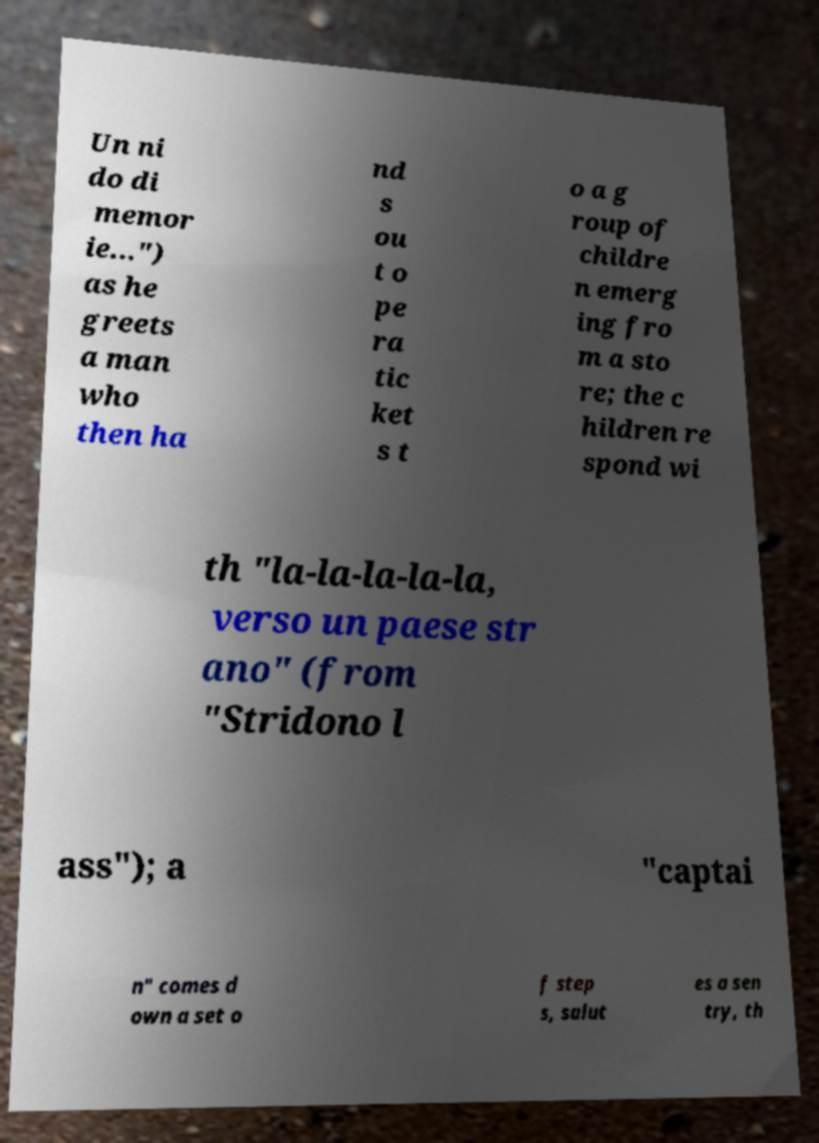I need the written content from this picture converted into text. Can you do that? Un ni do di memor ie...") as he greets a man who then ha nd s ou t o pe ra tic ket s t o a g roup of childre n emerg ing fro m a sto re; the c hildren re spond wi th "la-la-la-la-la, verso un paese str ano" (from "Stridono l ass"); a "captai n" comes d own a set o f step s, salut es a sen try, th 